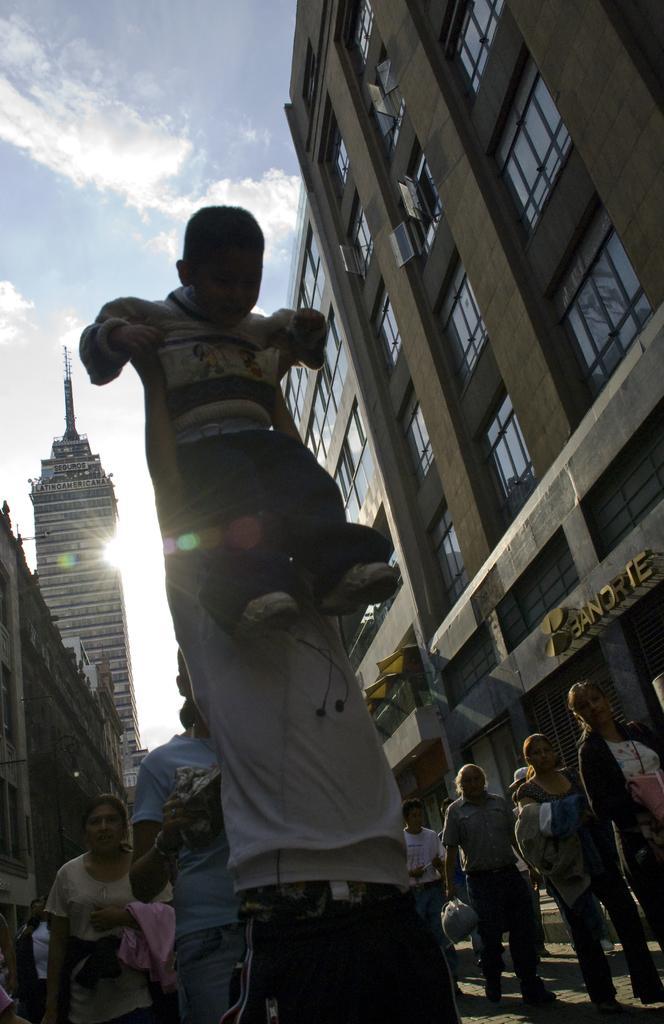How would you summarize this image in a sentence or two? In this image I can see group of people are standing on the road. Here I can see a person is holding a child. In the background I can see buildings, the sun and the sky. 